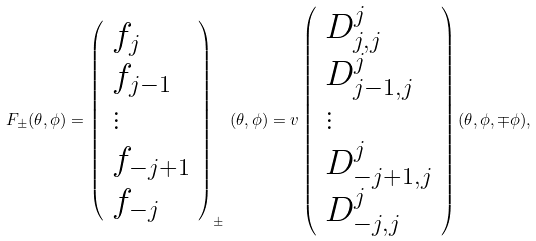<formula> <loc_0><loc_0><loc_500><loc_500>F _ { \pm } ( \theta , \phi ) = \left ( \begin{array} { l } f _ { j } \\ f _ { j - 1 } \\ \vdots \\ f _ { - j + 1 } \\ f _ { - j } \end{array} \right ) _ { \pm } \, ( \theta , \phi ) = v \left ( \begin{array} { l } D ^ { j } _ { j , j } \\ D ^ { j } _ { j - 1 , j } \\ \vdots \\ D ^ { j } _ { - j + 1 , j } \\ D ^ { j } _ { - j , j } \end{array} \right ) ( \theta , \phi , \mp \phi ) ,</formula> 